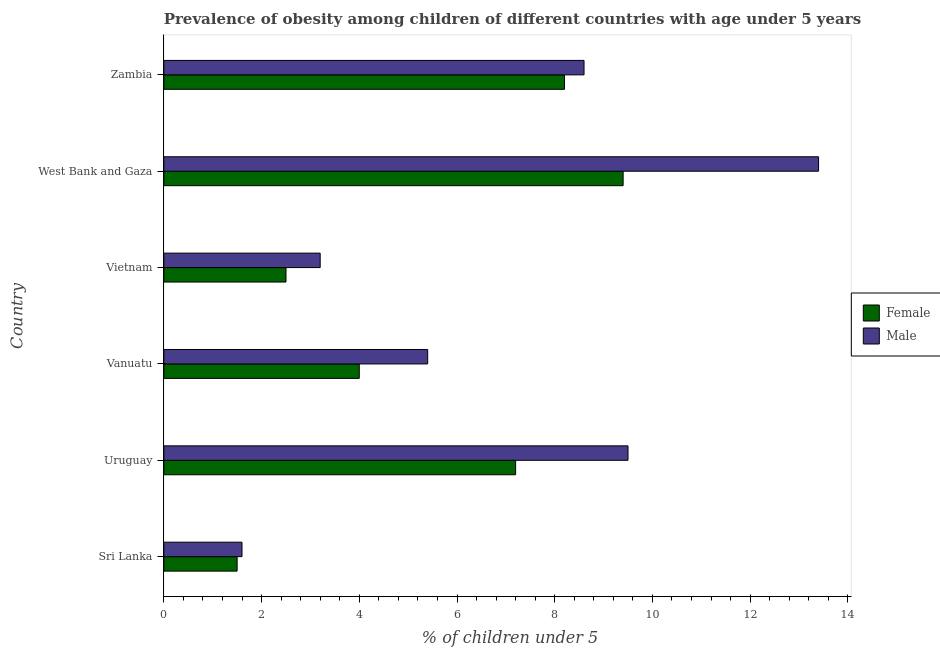How many different coloured bars are there?
Your answer should be very brief. 2. How many groups of bars are there?
Offer a terse response. 6. Are the number of bars per tick equal to the number of legend labels?
Offer a terse response. Yes. How many bars are there on the 3rd tick from the top?
Ensure brevity in your answer.  2. What is the label of the 3rd group of bars from the top?
Ensure brevity in your answer.  Vietnam. In how many cases, is the number of bars for a given country not equal to the number of legend labels?
Your response must be concise. 0. Across all countries, what is the maximum percentage of obese female children?
Make the answer very short. 9.4. Across all countries, what is the minimum percentage of obese female children?
Ensure brevity in your answer.  1.5. In which country was the percentage of obese male children maximum?
Provide a succinct answer. West Bank and Gaza. In which country was the percentage of obese male children minimum?
Ensure brevity in your answer.  Sri Lanka. What is the total percentage of obese female children in the graph?
Your answer should be compact. 32.8. What is the difference between the percentage of obese male children in Uruguay and that in Vanuatu?
Make the answer very short. 4.1. What is the difference between the percentage of obese female children in Sri Lanka and the percentage of obese male children in West Bank and Gaza?
Make the answer very short. -11.9. What is the average percentage of obese female children per country?
Your response must be concise. 5.47. What is the difference between the percentage of obese male children and percentage of obese female children in Vanuatu?
Ensure brevity in your answer.  1.4. What is the ratio of the percentage of obese female children in Vietnam to that in West Bank and Gaza?
Provide a short and direct response. 0.27. Is the percentage of obese female children in Sri Lanka less than that in Vanuatu?
Your answer should be very brief. Yes. Is the difference between the percentage of obese male children in Sri Lanka and Vietnam greater than the difference between the percentage of obese female children in Sri Lanka and Vietnam?
Make the answer very short. No. What is the difference between the highest and the second highest percentage of obese male children?
Provide a succinct answer. 3.9. What does the 2nd bar from the bottom in Zambia represents?
Your answer should be very brief. Male. What is the difference between two consecutive major ticks on the X-axis?
Offer a very short reply. 2. Are the values on the major ticks of X-axis written in scientific E-notation?
Give a very brief answer. No. Does the graph contain grids?
Make the answer very short. No. How many legend labels are there?
Make the answer very short. 2. What is the title of the graph?
Provide a short and direct response. Prevalence of obesity among children of different countries with age under 5 years. What is the label or title of the X-axis?
Your answer should be compact.  % of children under 5. What is the label or title of the Y-axis?
Give a very brief answer. Country. What is the  % of children under 5 of Male in Sri Lanka?
Offer a terse response. 1.6. What is the  % of children under 5 in Female in Uruguay?
Offer a terse response. 7.2. What is the  % of children under 5 in Male in Uruguay?
Your response must be concise. 9.5. What is the  % of children under 5 of Female in Vanuatu?
Give a very brief answer. 4. What is the  % of children under 5 in Male in Vanuatu?
Your answer should be compact. 5.4. What is the  % of children under 5 of Male in Vietnam?
Provide a short and direct response. 3.2. What is the  % of children under 5 in Female in West Bank and Gaza?
Ensure brevity in your answer.  9.4. What is the  % of children under 5 in Male in West Bank and Gaza?
Give a very brief answer. 13.4. What is the  % of children under 5 in Female in Zambia?
Your answer should be compact. 8.2. What is the  % of children under 5 of Male in Zambia?
Provide a succinct answer. 8.6. Across all countries, what is the maximum  % of children under 5 in Female?
Your response must be concise. 9.4. Across all countries, what is the maximum  % of children under 5 of Male?
Your answer should be very brief. 13.4. Across all countries, what is the minimum  % of children under 5 of Female?
Make the answer very short. 1.5. Across all countries, what is the minimum  % of children under 5 in Male?
Your response must be concise. 1.6. What is the total  % of children under 5 in Female in the graph?
Make the answer very short. 32.8. What is the total  % of children under 5 in Male in the graph?
Provide a succinct answer. 41.7. What is the difference between the  % of children under 5 of Female in Sri Lanka and that in Uruguay?
Make the answer very short. -5.7. What is the difference between the  % of children under 5 in Male in Sri Lanka and that in Uruguay?
Your answer should be very brief. -7.9. What is the difference between the  % of children under 5 in Female in Sri Lanka and that in Vietnam?
Your answer should be compact. -1. What is the difference between the  % of children under 5 in Female in Sri Lanka and that in Zambia?
Offer a terse response. -6.7. What is the difference between the  % of children under 5 in Female in Uruguay and that in Vanuatu?
Provide a succinct answer. 3.2. What is the difference between the  % of children under 5 of Male in Uruguay and that in Vanuatu?
Make the answer very short. 4.1. What is the difference between the  % of children under 5 in Female in Uruguay and that in Vietnam?
Give a very brief answer. 4.7. What is the difference between the  % of children under 5 in Male in Uruguay and that in Zambia?
Provide a succinct answer. 0.9. What is the difference between the  % of children under 5 of Female in Vanuatu and that in Vietnam?
Offer a very short reply. 1.5. What is the difference between the  % of children under 5 of Female in Vanuatu and that in West Bank and Gaza?
Offer a very short reply. -5.4. What is the difference between the  % of children under 5 of Male in Vanuatu and that in Zambia?
Ensure brevity in your answer.  -3.2. What is the difference between the  % of children under 5 in Male in Vietnam and that in West Bank and Gaza?
Your answer should be very brief. -10.2. What is the difference between the  % of children under 5 in Female in Vietnam and that in Zambia?
Make the answer very short. -5.7. What is the difference between the  % of children under 5 in Male in Vietnam and that in Zambia?
Offer a very short reply. -5.4. What is the difference between the  % of children under 5 in Male in West Bank and Gaza and that in Zambia?
Offer a very short reply. 4.8. What is the difference between the  % of children under 5 in Female in Sri Lanka and the  % of children under 5 in Male in Uruguay?
Provide a short and direct response. -8. What is the difference between the  % of children under 5 of Female in Sri Lanka and the  % of children under 5 of Male in Vanuatu?
Your answer should be compact. -3.9. What is the difference between the  % of children under 5 in Female in Sri Lanka and the  % of children under 5 in Male in West Bank and Gaza?
Your answer should be very brief. -11.9. What is the difference between the  % of children under 5 in Female in Sri Lanka and the  % of children under 5 in Male in Zambia?
Make the answer very short. -7.1. What is the difference between the  % of children under 5 of Female in Uruguay and the  % of children under 5 of Male in Vietnam?
Your answer should be compact. 4. What is the difference between the  % of children under 5 of Female in Uruguay and the  % of children under 5 of Male in West Bank and Gaza?
Offer a very short reply. -6.2. What is the difference between the  % of children under 5 in Female in Uruguay and the  % of children under 5 in Male in Zambia?
Give a very brief answer. -1.4. What is the difference between the  % of children under 5 of Female in Vanuatu and the  % of children under 5 of Male in West Bank and Gaza?
Your answer should be compact. -9.4. What is the difference between the  % of children under 5 of Female in Vanuatu and the  % of children under 5 of Male in Zambia?
Your answer should be very brief. -4.6. What is the difference between the  % of children under 5 of Female in Vietnam and the  % of children under 5 of Male in West Bank and Gaza?
Your answer should be very brief. -10.9. What is the average  % of children under 5 in Female per country?
Keep it short and to the point. 5.47. What is the average  % of children under 5 in Male per country?
Keep it short and to the point. 6.95. What is the difference between the  % of children under 5 of Female and  % of children under 5 of Male in West Bank and Gaza?
Provide a succinct answer. -4. What is the ratio of the  % of children under 5 in Female in Sri Lanka to that in Uruguay?
Offer a terse response. 0.21. What is the ratio of the  % of children under 5 of Male in Sri Lanka to that in Uruguay?
Your answer should be compact. 0.17. What is the ratio of the  % of children under 5 of Male in Sri Lanka to that in Vanuatu?
Keep it short and to the point. 0.3. What is the ratio of the  % of children under 5 in Male in Sri Lanka to that in Vietnam?
Make the answer very short. 0.5. What is the ratio of the  % of children under 5 in Female in Sri Lanka to that in West Bank and Gaza?
Keep it short and to the point. 0.16. What is the ratio of the  % of children under 5 of Male in Sri Lanka to that in West Bank and Gaza?
Your response must be concise. 0.12. What is the ratio of the  % of children under 5 in Female in Sri Lanka to that in Zambia?
Offer a very short reply. 0.18. What is the ratio of the  % of children under 5 of Male in Sri Lanka to that in Zambia?
Your answer should be compact. 0.19. What is the ratio of the  % of children under 5 in Male in Uruguay to that in Vanuatu?
Ensure brevity in your answer.  1.76. What is the ratio of the  % of children under 5 in Female in Uruguay to that in Vietnam?
Offer a very short reply. 2.88. What is the ratio of the  % of children under 5 in Male in Uruguay to that in Vietnam?
Give a very brief answer. 2.97. What is the ratio of the  % of children under 5 in Female in Uruguay to that in West Bank and Gaza?
Ensure brevity in your answer.  0.77. What is the ratio of the  % of children under 5 of Male in Uruguay to that in West Bank and Gaza?
Your answer should be compact. 0.71. What is the ratio of the  % of children under 5 of Female in Uruguay to that in Zambia?
Your answer should be very brief. 0.88. What is the ratio of the  % of children under 5 of Male in Uruguay to that in Zambia?
Your answer should be compact. 1.1. What is the ratio of the  % of children under 5 in Female in Vanuatu to that in Vietnam?
Provide a short and direct response. 1.6. What is the ratio of the  % of children under 5 in Male in Vanuatu to that in Vietnam?
Your answer should be compact. 1.69. What is the ratio of the  % of children under 5 in Female in Vanuatu to that in West Bank and Gaza?
Your response must be concise. 0.43. What is the ratio of the  % of children under 5 of Male in Vanuatu to that in West Bank and Gaza?
Your answer should be compact. 0.4. What is the ratio of the  % of children under 5 of Female in Vanuatu to that in Zambia?
Offer a terse response. 0.49. What is the ratio of the  % of children under 5 of Male in Vanuatu to that in Zambia?
Your answer should be compact. 0.63. What is the ratio of the  % of children under 5 of Female in Vietnam to that in West Bank and Gaza?
Provide a short and direct response. 0.27. What is the ratio of the  % of children under 5 of Male in Vietnam to that in West Bank and Gaza?
Give a very brief answer. 0.24. What is the ratio of the  % of children under 5 of Female in Vietnam to that in Zambia?
Offer a very short reply. 0.3. What is the ratio of the  % of children under 5 in Male in Vietnam to that in Zambia?
Offer a terse response. 0.37. What is the ratio of the  % of children under 5 in Female in West Bank and Gaza to that in Zambia?
Give a very brief answer. 1.15. What is the ratio of the  % of children under 5 in Male in West Bank and Gaza to that in Zambia?
Your answer should be very brief. 1.56. What is the difference between the highest and the second highest  % of children under 5 in Male?
Keep it short and to the point. 3.9. What is the difference between the highest and the lowest  % of children under 5 of Female?
Your response must be concise. 7.9. 